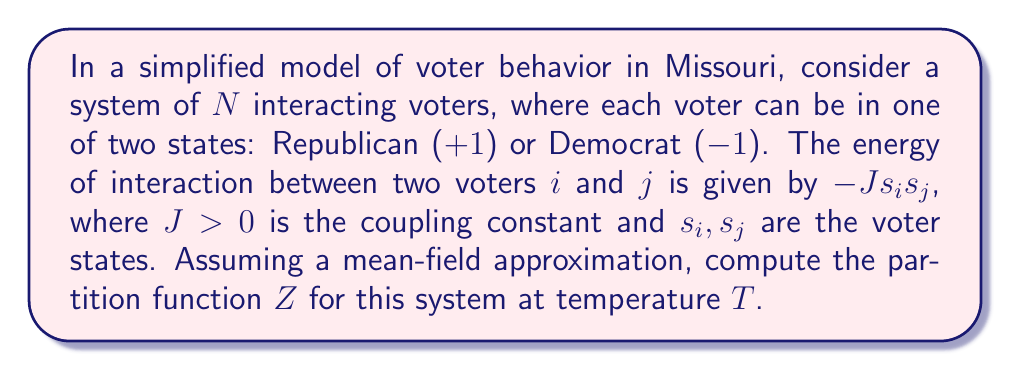What is the answer to this math problem? To solve this problem, we'll follow these steps:

1) In the mean-field approximation, we assume each voter interacts equally with all other voters. The total energy of the system is:

   $$E = -\frac{J}{2N} \left(\sum_{i=1}^N s_i\right)^2$$

2) Let $m = \frac{1}{N}\sum_{i=1}^N s_i$ be the average voter state. Then $E = -\frac{JN}{2}m^2$.

3) The partition function is given by:

   $$Z = \sum_{\{s_i\}} e^{-\beta E}$$

   where $\beta = \frac{1}{k_B T}$, $k_B$ is Boltzmann's constant, and the sum is over all possible configurations.

4) Substituting the energy:

   $$Z = \sum_{\{s_i\}} \exp\left(\frac{\beta JN}{2}m^2\right)$$

5) Using the definition of $m$:

   $$Z = \sum_{\{s_i\}} \exp\left(\frac{\beta J}{2N}\left(\sum_{i=1}^N s_i\right)^2\right)$$

6) We can separate the sum over configurations into sums over individual voter states:

   $$Z = \sum_{s_1=\pm1} \sum_{s_2=\pm1} ... \sum_{s_N=\pm1} \exp\left(\frac{\beta J}{2N}\left(\sum_{i=1}^N s_i\right)^2\right)$$

7) This can be written as an integral using the Hubbard-Stratonovich transformation:

   $$Z = \sqrt{\frac{N}{2\pi\beta J}} \int_{-\infty}^{\infty} dx \exp\left(-\frac{Nx^2}{2\beta J}\right) \left(\sum_{s=\pm1} e^{sx}\right)^N$$

8) Simplifying the sum inside the parentheses:

   $$Z = \sqrt{\frac{N}{2\pi\beta J}} \int_{-\infty}^{\infty} dx \exp\left(-\frac{Nx^2}{2\beta J}\right) (2\cosh x)^N$$

This is the partition function for the system of interacting voters in the mean-field approximation.
Answer: $$Z = \sqrt{\frac{N}{2\pi\beta J}} \int_{-\infty}^{\infty} dx \exp\left(-\frac{Nx^2}{2\beta J}\right) (2\cosh x)^N$$ 